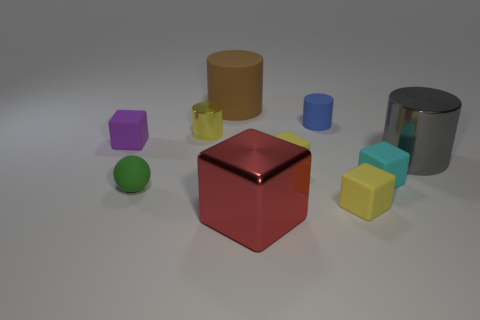Subtract all purple matte blocks. How many blocks are left? 4 Subtract all purple blocks. How many blocks are left? 4 Subtract all cyan cylinders. Subtract all red blocks. How many cylinders are left? 4 Subtract all cylinders. How many objects are left? 6 Subtract all blue matte cylinders. Subtract all tiny cyan rubber cubes. How many objects are left? 8 Add 2 small green balls. How many small green balls are left? 3 Add 8 green balls. How many green balls exist? 9 Subtract 0 cyan spheres. How many objects are left? 10 